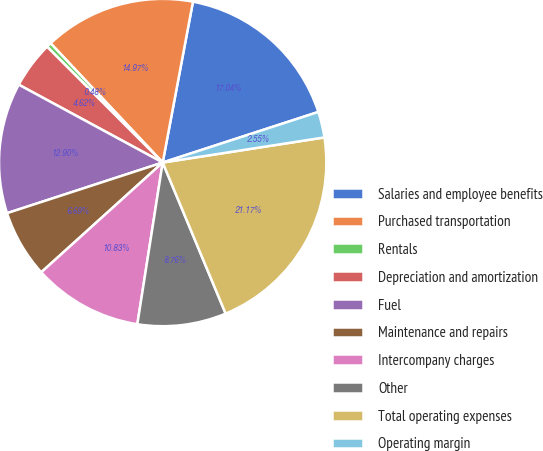Convert chart to OTSL. <chart><loc_0><loc_0><loc_500><loc_500><pie_chart><fcel>Salaries and employee benefits<fcel>Purchased transportation<fcel>Rentals<fcel>Depreciation and amortization<fcel>Fuel<fcel>Maintenance and repairs<fcel>Intercompany charges<fcel>Other<fcel>Total operating expenses<fcel>Operating margin<nl><fcel>17.04%<fcel>14.97%<fcel>0.48%<fcel>4.62%<fcel>12.9%<fcel>6.69%<fcel>10.83%<fcel>8.76%<fcel>21.17%<fcel>2.55%<nl></chart> 